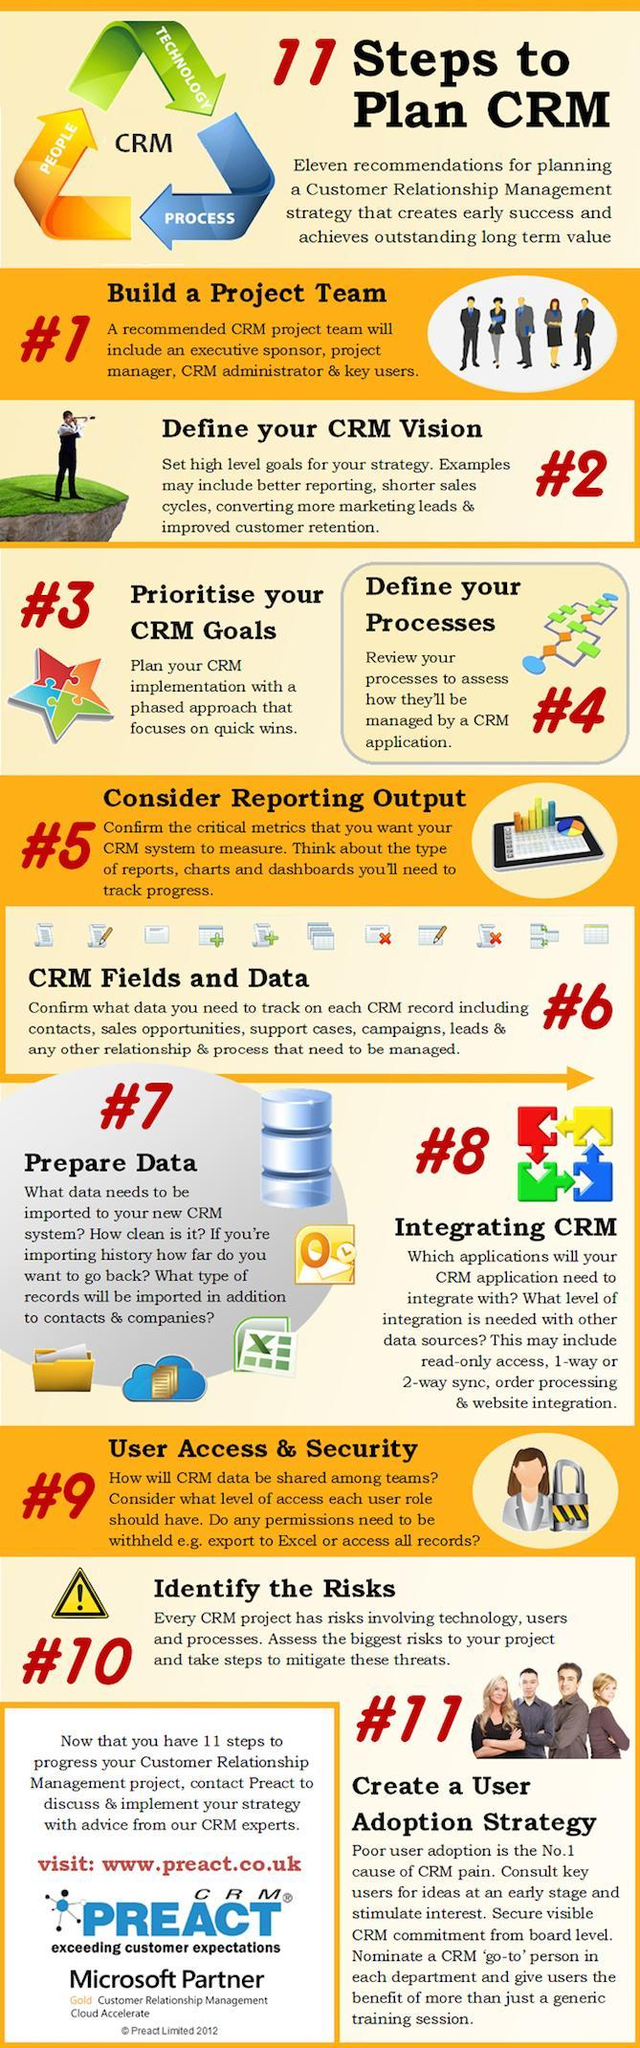Name the next step that comes after step 3 in the CRM recommendations?
Answer the question with a short phrase. Define your Processes What are the three things that Customer Relationship Management connects? People, Technology, Process Name the step that comes before step 8 in the CRM recommendations? Prepare Data 